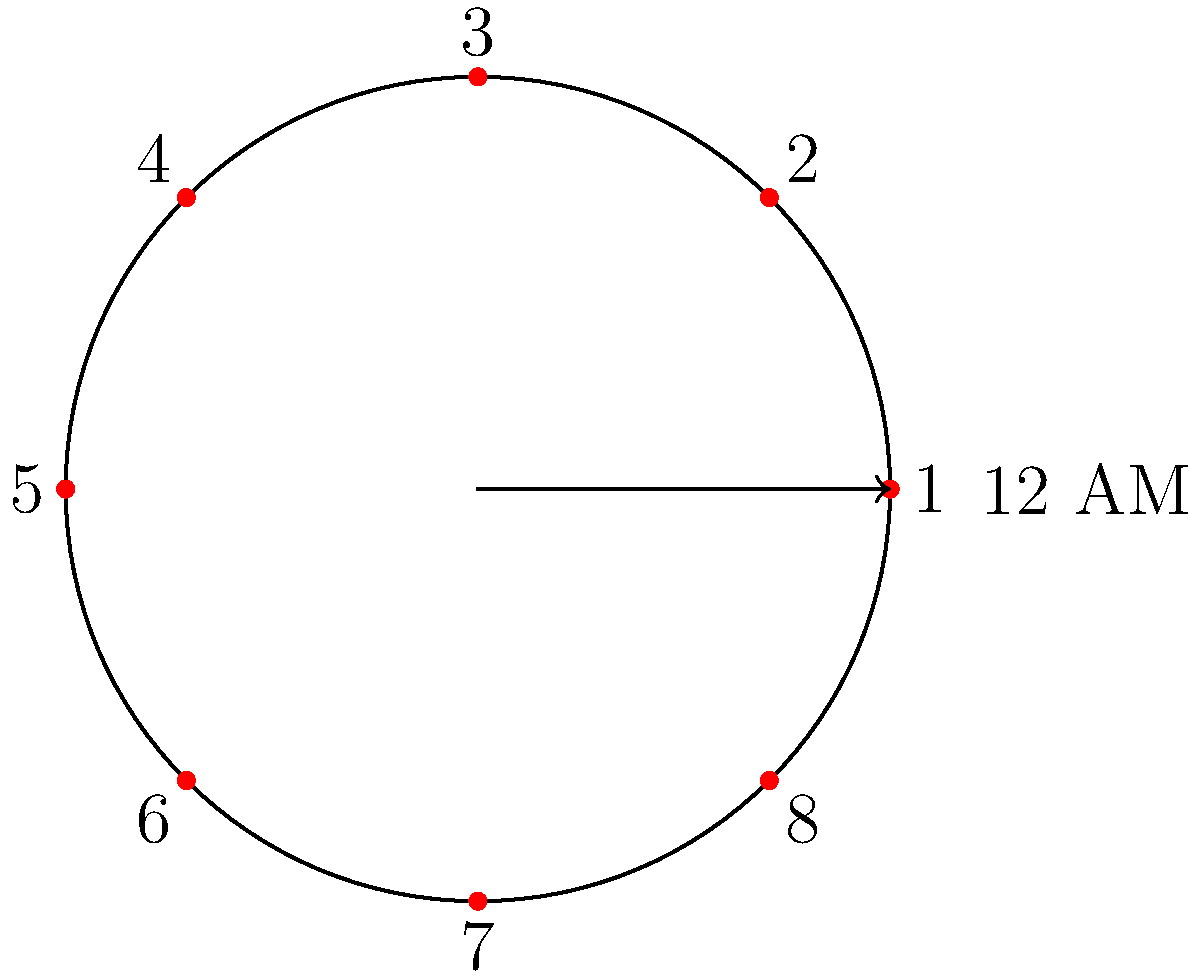You want to design an efficient 8-hour shift rotation for your employees using a circular diagram. The diagram shows 8 equally spaced points on a circle, numbered 1 to 8, with 12 AM at the rightmost point. If an employee starts their shift at point 1 and works clockwise for 8 hours, what is the optimal starting point for the next employee's shift to ensure continuous coverage with minimal overlap? Let's approach this step-by-step:

1) Each point on the circle represents a 3-hour interval (24 hours / 8 points = 3 hours per point).

2) An 8-hour shift covers slightly more than 2.5 points on the circle (8 hours / 3 hours per point ≈ 2.67 points).

3) If the first employee starts at point 1, their shift will end just past point 3.

4) To ensure continuous coverage with minimal overlap, the next employee should start their shift at the point where the previous shift ends.

5) The closest whole number point to where the first shift ends is point 4.

6) Starting the next shift at point 4 will provide a small overlap for shift handover, which is beneficial for continuity of operations.

7) This pattern can be continued: the third shift would start at point 7, and the cycle would repeat with the fourth shift starting back at point 1.

Therefore, the optimal starting point for the next employee's shift is point 4 on the circular diagram.
Answer: Point 4 